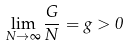<formula> <loc_0><loc_0><loc_500><loc_500>\lim _ { N \to \infty } \frac { G } { N } = g > 0</formula> 